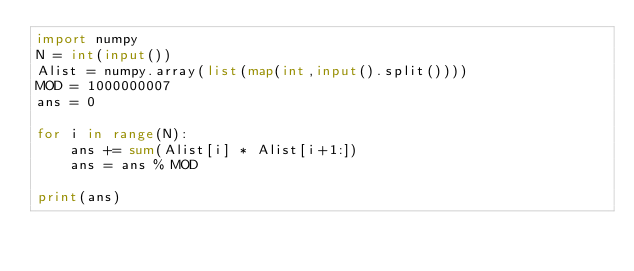Convert code to text. <code><loc_0><loc_0><loc_500><loc_500><_Python_>import numpy
N = int(input())
Alist = numpy.array(list(map(int,input().split())))
MOD = 1000000007
ans = 0

for i in range(N):
    ans += sum(Alist[i] * Alist[i+1:])
    ans = ans % MOD

print(ans)</code> 